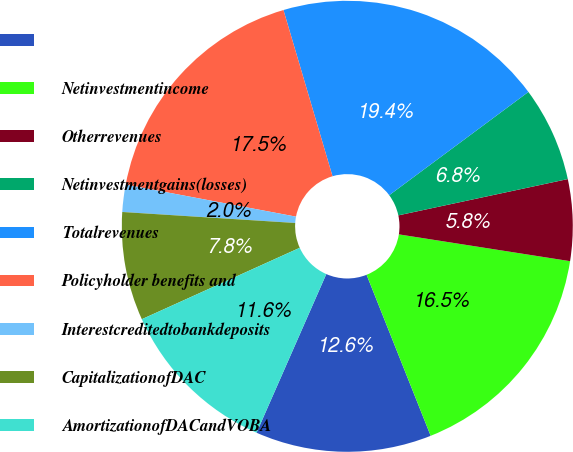Convert chart. <chart><loc_0><loc_0><loc_500><loc_500><pie_chart><ecel><fcel>Netinvestmentincome<fcel>Otherrevenues<fcel>Netinvestmentgains(losses)<fcel>Totalrevenues<fcel>Policyholder benefits and<fcel>Interestcreditedtobankdeposits<fcel>CapitalizationofDAC<fcel>AmortizationofDACandVOBA<nl><fcel>12.62%<fcel>16.5%<fcel>5.83%<fcel>6.8%<fcel>19.41%<fcel>17.47%<fcel>1.95%<fcel>7.77%<fcel>11.65%<nl></chart> 